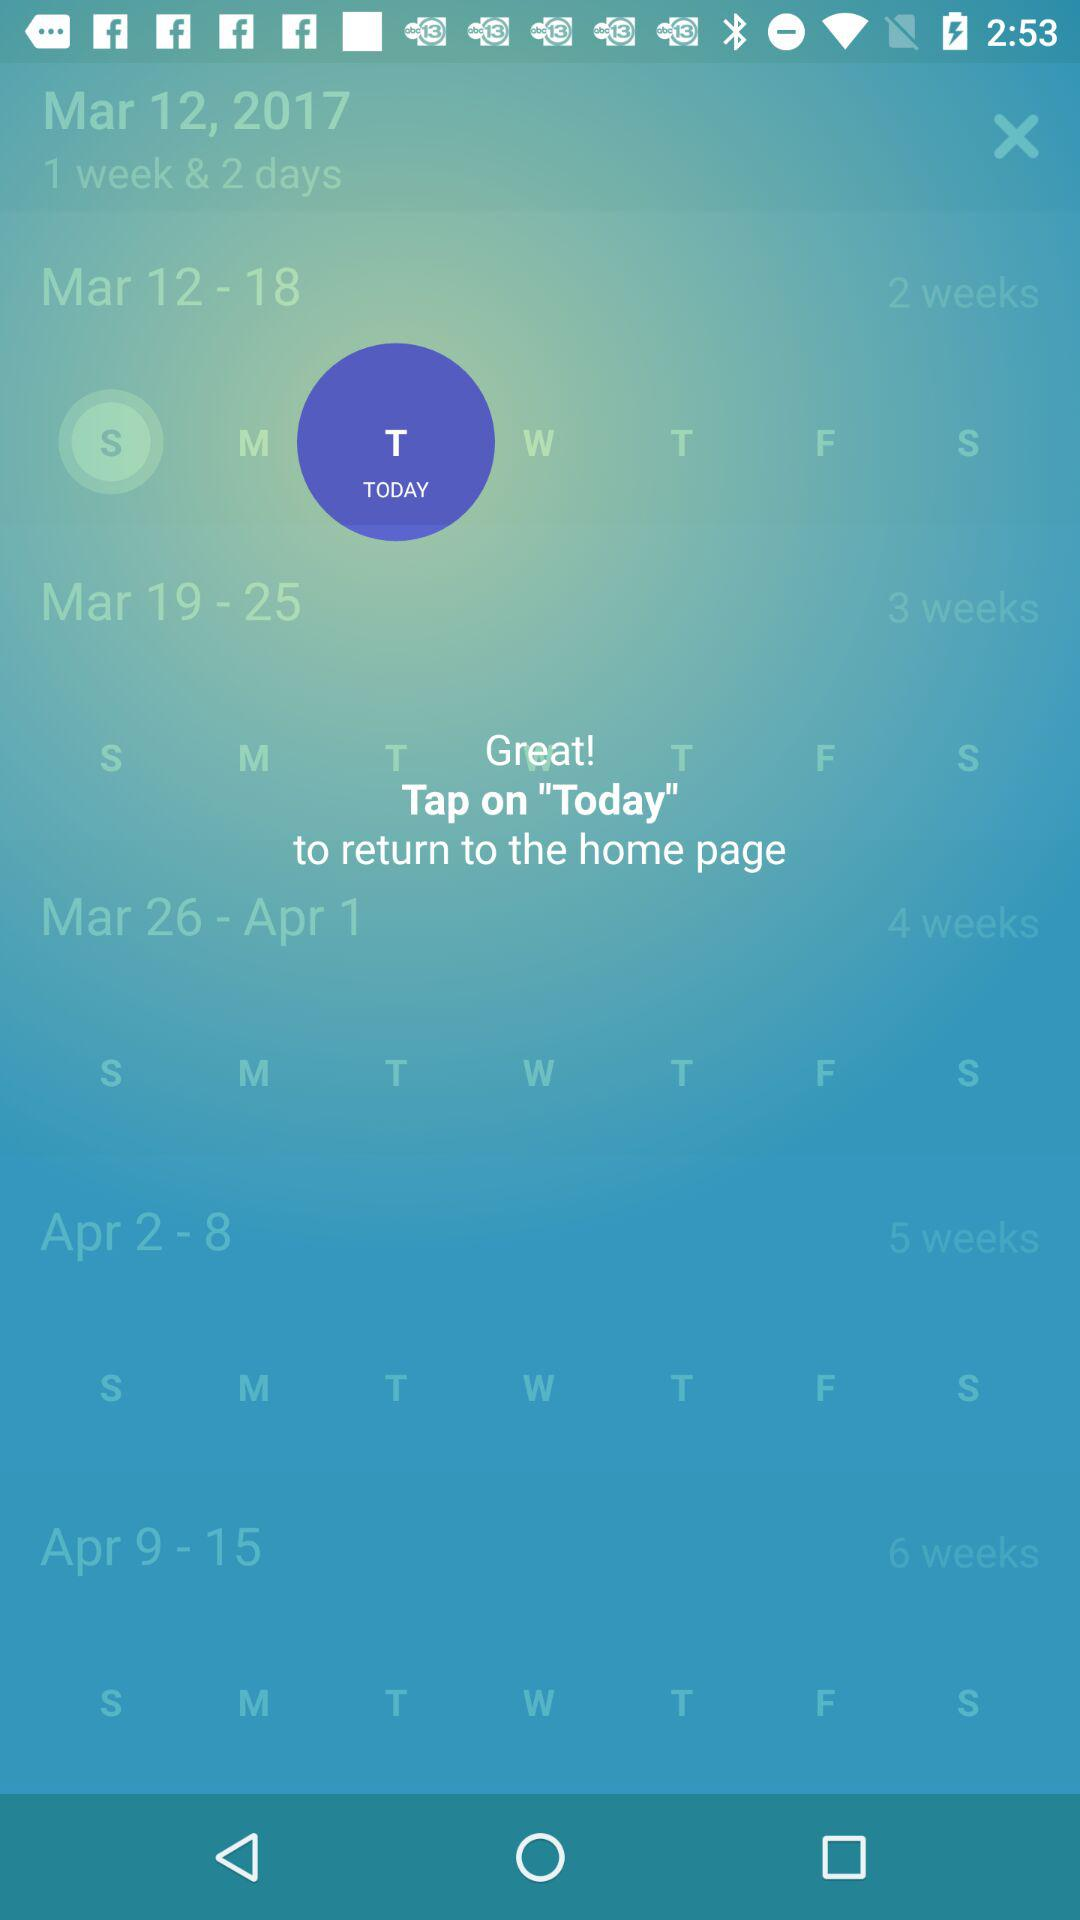What is today's date selected?
When the provided information is insufficient, respond with <no answer>. <no answer> 